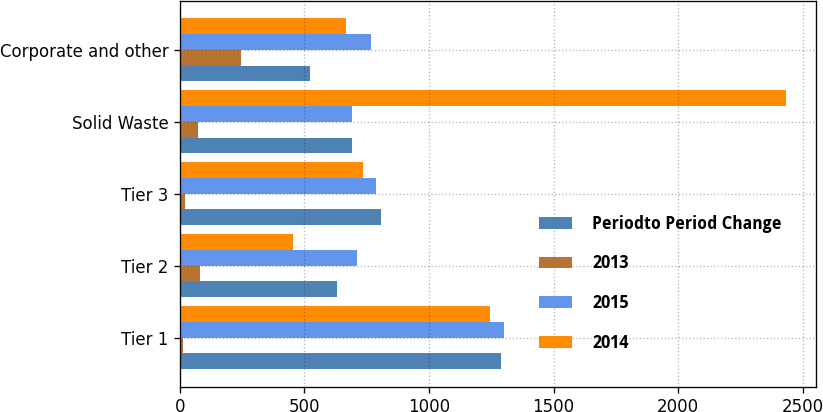Convert chart to OTSL. <chart><loc_0><loc_0><loc_500><loc_500><stacked_bar_chart><ecel><fcel>Tier 1<fcel>Tier 2<fcel>Tier 3<fcel>Solid Waste<fcel>Corporate and other<nl><fcel>Periodto Period Change<fcel>1290<fcel>629<fcel>808<fcel>689<fcel>522<nl><fcel>2013<fcel>11<fcel>82<fcel>21<fcel>72<fcel>247<nl><fcel>2015<fcel>1301<fcel>711<fcel>787<fcel>689<fcel>769<nl><fcel>2014<fcel>1246<fcel>454<fcel>734<fcel>2434<fcel>667<nl></chart> 